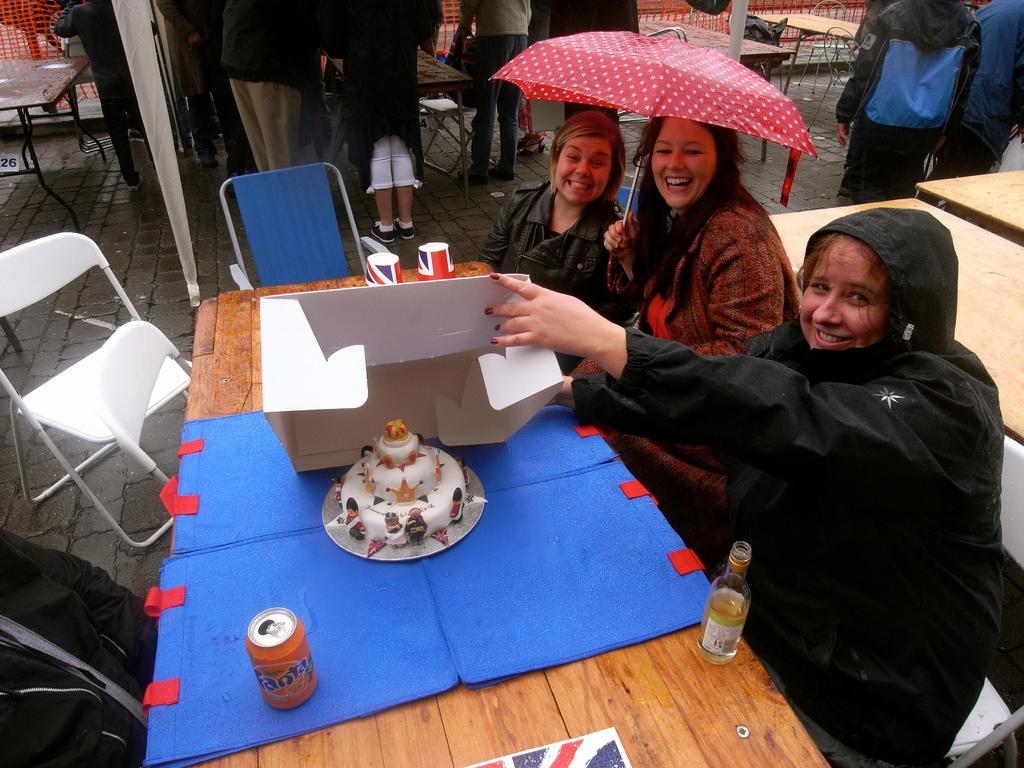How many women are in the image? There are three women in the image. What are the women doing in the image? The women are seated on chairs and holding an umbrella. What is on the table in the image? There is a cake, a bottle, and a can on the table. Are there any other people visible in the image? Yes, there are people standing in the background. What type of observation can be made about the scale of the cake in the image? There is no information provided about the scale of the cake in the image, so it cannot be determined. 